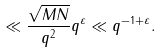Convert formula to latex. <formula><loc_0><loc_0><loc_500><loc_500>\ll \frac { \sqrt { M N } } { q ^ { 2 } } q ^ { \varepsilon } \ll q ^ { - 1 + \varepsilon } .</formula> 